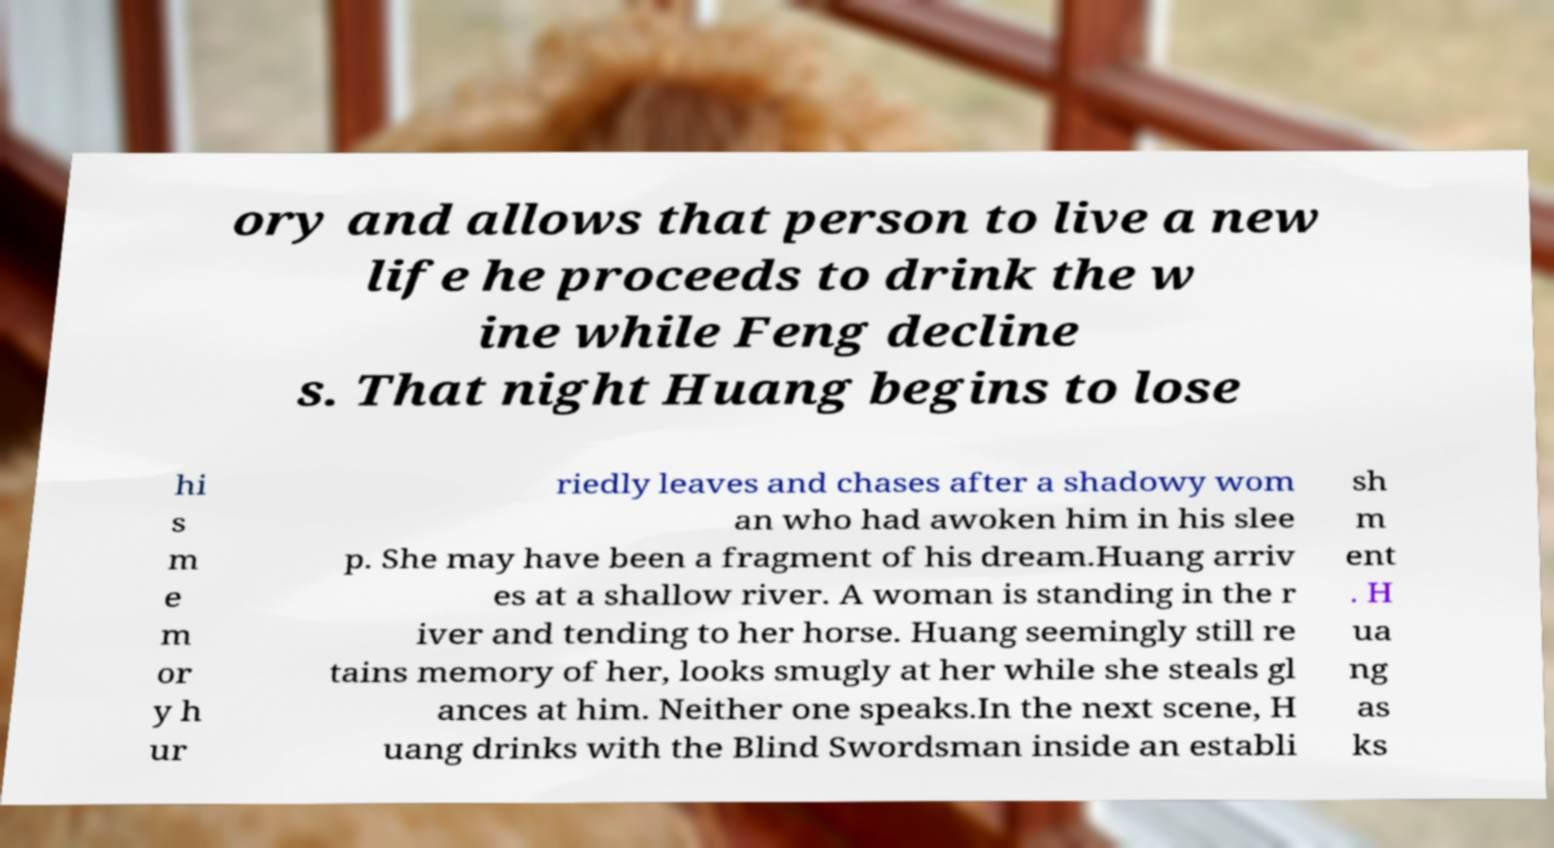Please identify and transcribe the text found in this image. ory and allows that person to live a new life he proceeds to drink the w ine while Feng decline s. That night Huang begins to lose hi s m e m or y h ur riedly leaves and chases after a shadowy wom an who had awoken him in his slee p. She may have been a fragment of his dream.Huang arriv es at a shallow river. A woman is standing in the r iver and tending to her horse. Huang seemingly still re tains memory of her, looks smugly at her while she steals gl ances at him. Neither one speaks.In the next scene, H uang drinks with the Blind Swordsman inside an establi sh m ent . H ua ng as ks 